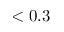<formula> <loc_0><loc_0><loc_500><loc_500>< 0 . 3</formula> 